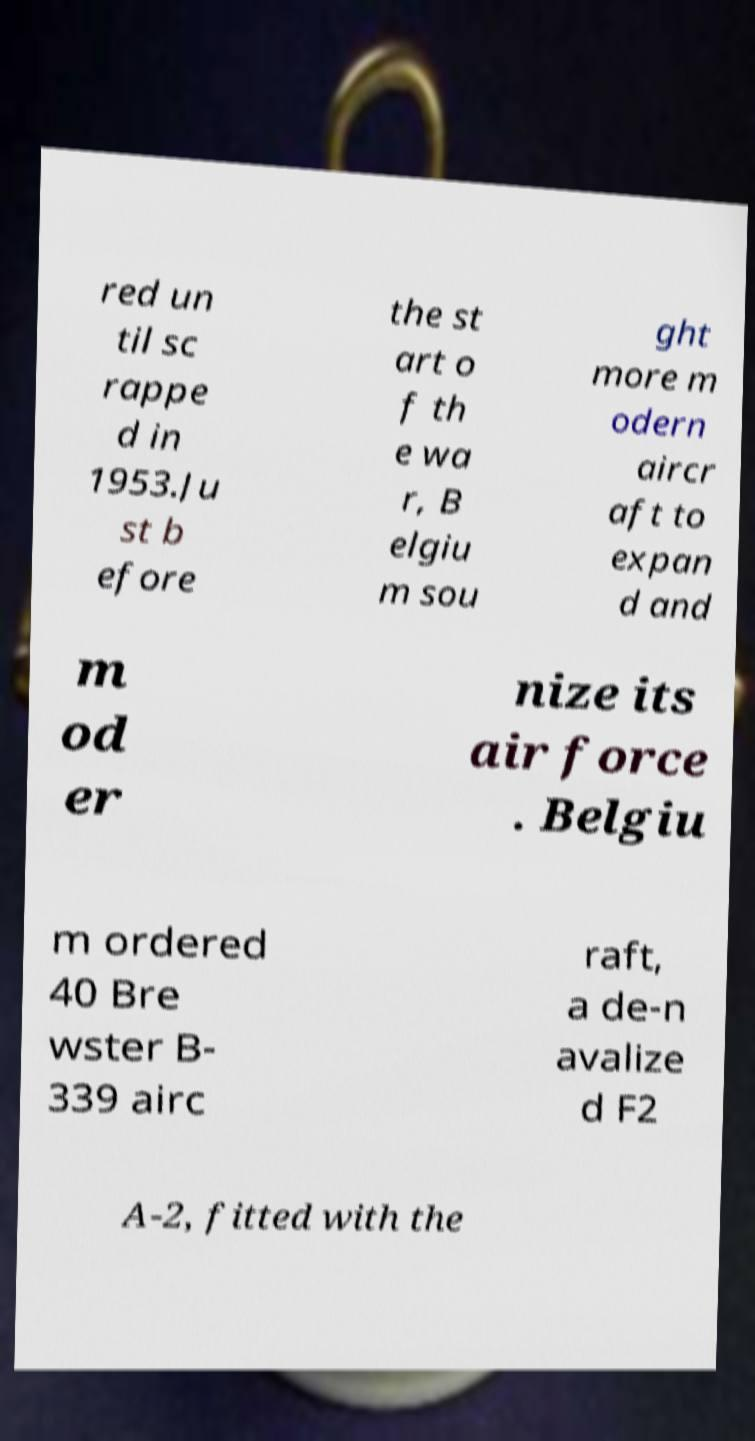What messages or text are displayed in this image? I need them in a readable, typed format. red un til sc rappe d in 1953.Ju st b efore the st art o f th e wa r, B elgiu m sou ght more m odern aircr aft to expan d and m od er nize its air force . Belgiu m ordered 40 Bre wster B- 339 airc raft, a de-n avalize d F2 A-2, fitted with the 